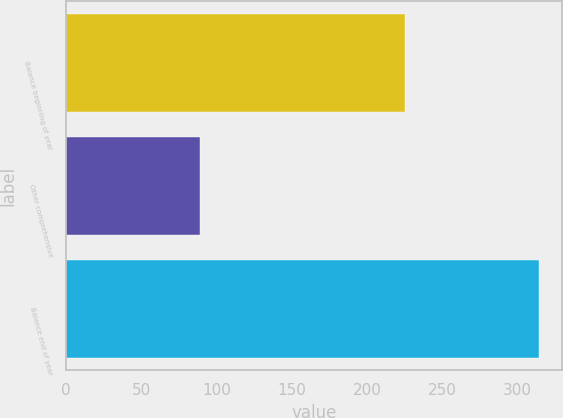<chart> <loc_0><loc_0><loc_500><loc_500><bar_chart><fcel>Balance beginning of year<fcel>Other comprehensive<fcel>Balance end of year<nl><fcel>225<fcel>89<fcel>314<nl></chart> 